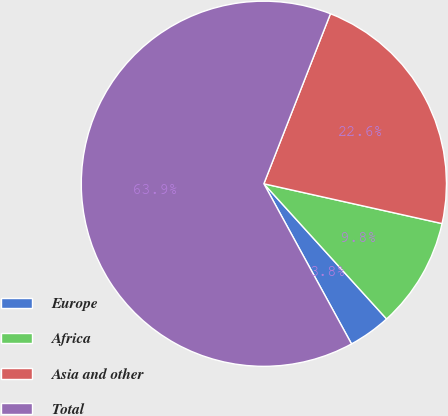<chart> <loc_0><loc_0><loc_500><loc_500><pie_chart><fcel>Europe<fcel>Africa<fcel>Asia and other<fcel>Total<nl><fcel>3.76%<fcel>9.77%<fcel>22.56%<fcel>63.91%<nl></chart> 